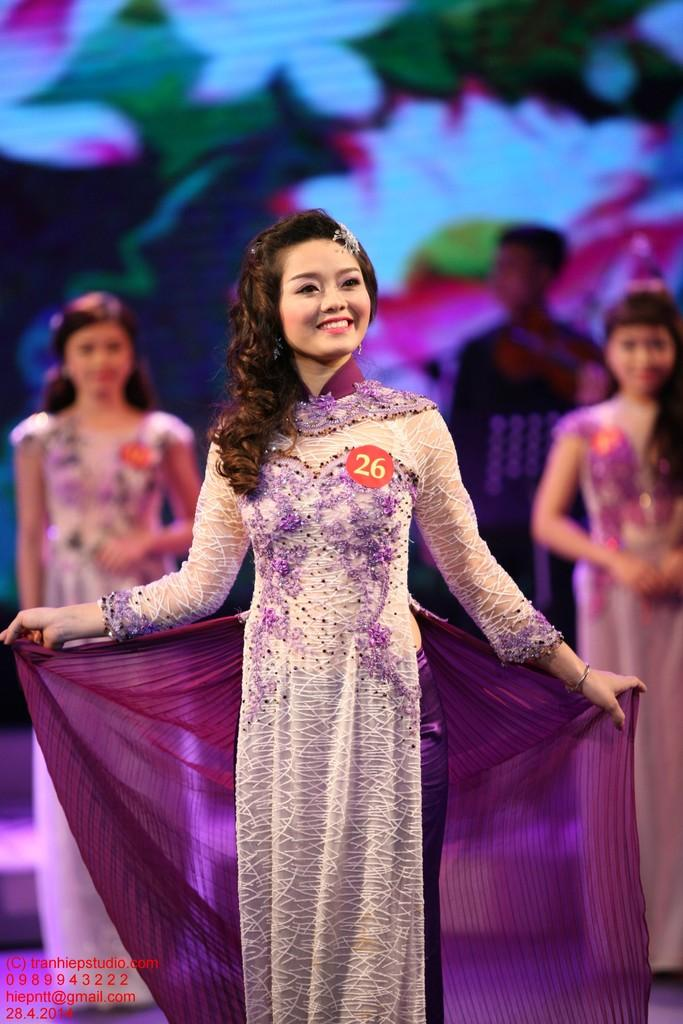Who is present in the image? There is a woman in the image. What is the woman wearing? The woman is wearing a cream and purple color dress. Can you describe any additional details about the woman's attire? The woman has a badge attached to her dress. What can be observed about the background of the image? The background of the image is blurry. What type of operation is being performed in the field in the image? There is no field or operation present in the image; it features a woman wearing a dress with a badge. 